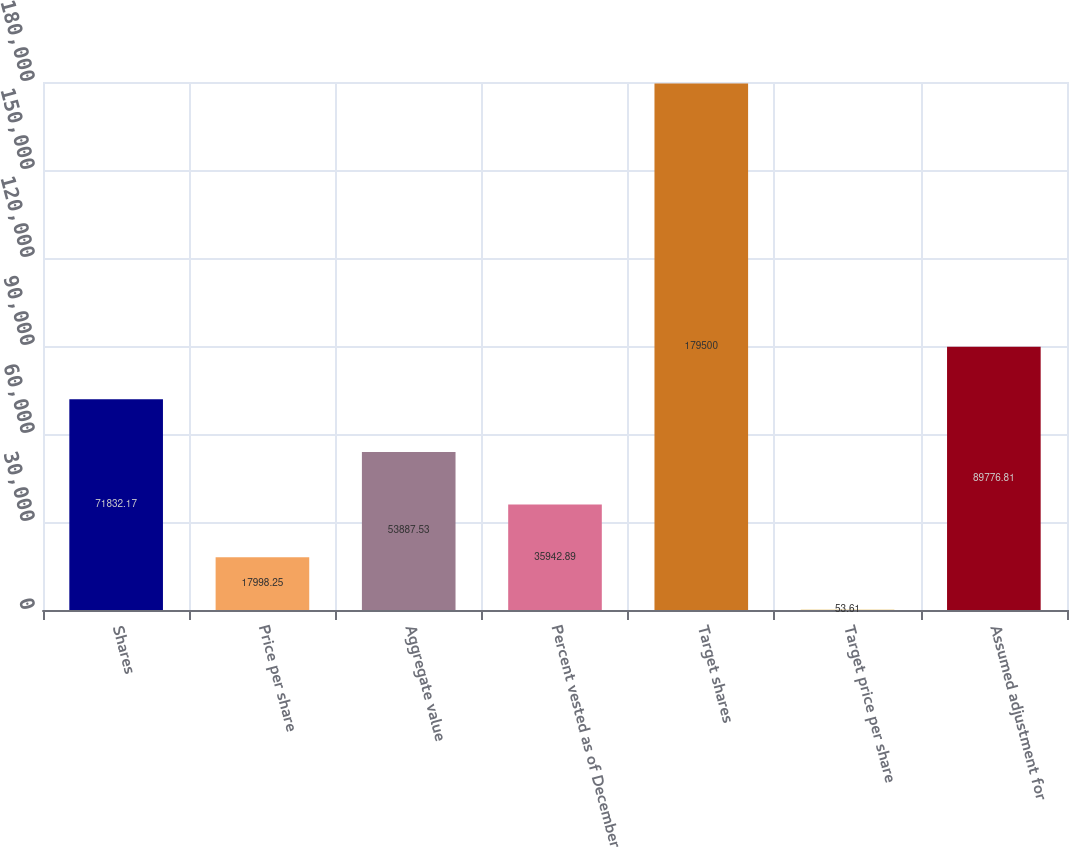Convert chart to OTSL. <chart><loc_0><loc_0><loc_500><loc_500><bar_chart><fcel>Shares<fcel>Price per share<fcel>Aggregate value<fcel>Percent vested as of December<fcel>Target shares<fcel>Target price per share<fcel>Assumed adjustment for<nl><fcel>71832.2<fcel>17998.2<fcel>53887.5<fcel>35942.9<fcel>179500<fcel>53.61<fcel>89776.8<nl></chart> 